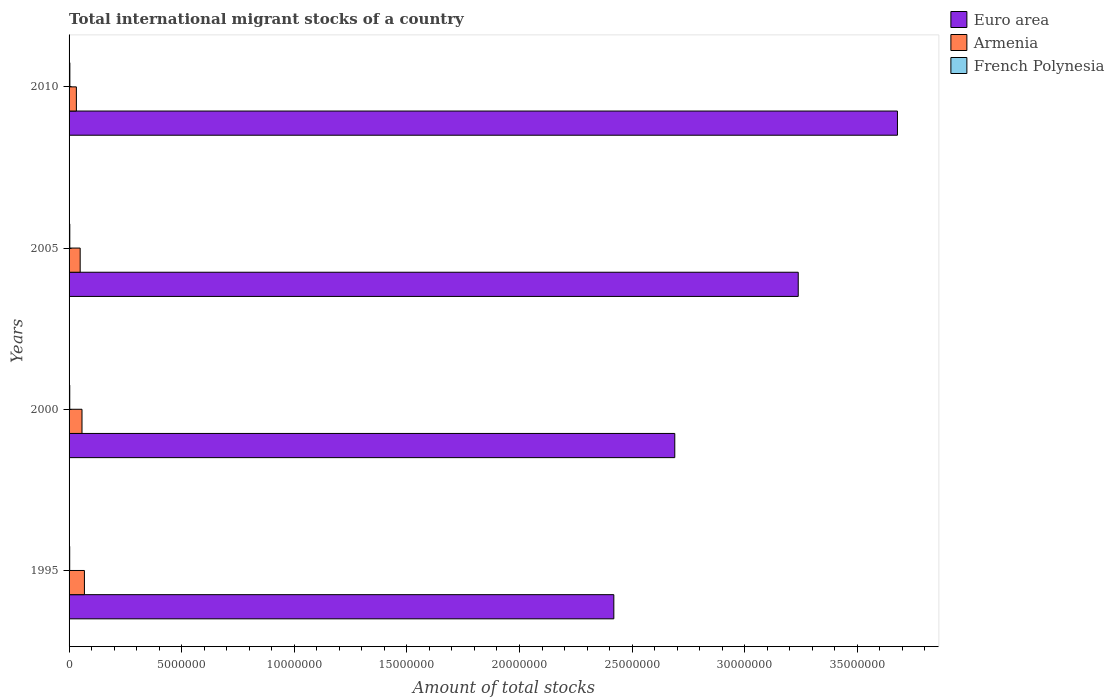Are the number of bars per tick equal to the number of legend labels?
Offer a terse response. Yes. Are the number of bars on each tick of the Y-axis equal?
Make the answer very short. Yes. What is the label of the 3rd group of bars from the top?
Offer a terse response. 2000. In how many cases, is the number of bars for a given year not equal to the number of legend labels?
Offer a very short reply. 0. What is the amount of total stocks in in Armenia in 2005?
Your answer should be very brief. 4.93e+05. Across all years, what is the maximum amount of total stocks in in Euro area?
Your answer should be very brief. 3.68e+07. Across all years, what is the minimum amount of total stocks in in Euro area?
Offer a very short reply. 2.42e+07. In which year was the amount of total stocks in in Euro area maximum?
Offer a very short reply. 2010. In which year was the amount of total stocks in in Euro area minimum?
Offer a very short reply. 1995. What is the total amount of total stocks in in Armenia in the graph?
Your answer should be compact. 2.07e+06. What is the difference between the amount of total stocks in in Euro area in 1995 and that in 2000?
Your answer should be compact. -2.71e+06. What is the difference between the amount of total stocks in in French Polynesia in 2010 and the amount of total stocks in in Euro area in 2005?
Ensure brevity in your answer.  -3.23e+07. What is the average amount of total stocks in in Armenia per year?
Provide a succinct answer. 5.18e+05. In the year 2000, what is the difference between the amount of total stocks in in French Polynesia and amount of total stocks in in Euro area?
Keep it short and to the point. -2.69e+07. What is the ratio of the amount of total stocks in in French Polynesia in 1995 to that in 2000?
Offer a terse response. 0.93. What is the difference between the highest and the second highest amount of total stocks in in French Polynesia?
Offer a terse response. 2314. What is the difference between the highest and the lowest amount of total stocks in in Euro area?
Keep it short and to the point. 1.26e+07. Is the sum of the amount of total stocks in in Armenia in 1995 and 2010 greater than the maximum amount of total stocks in in French Polynesia across all years?
Offer a terse response. Yes. What does the 1st bar from the top in 2005 represents?
Offer a very short reply. French Polynesia. What does the 3rd bar from the bottom in 1995 represents?
Keep it short and to the point. French Polynesia. How many years are there in the graph?
Ensure brevity in your answer.  4. What is the difference between two consecutive major ticks on the X-axis?
Your answer should be very brief. 5.00e+06. Are the values on the major ticks of X-axis written in scientific E-notation?
Give a very brief answer. No. How many legend labels are there?
Give a very brief answer. 3. How are the legend labels stacked?
Your answer should be very brief. Vertical. What is the title of the graph?
Offer a very short reply. Total international migrant stocks of a country. Does "Lesotho" appear as one of the legend labels in the graph?
Keep it short and to the point. No. What is the label or title of the X-axis?
Provide a short and direct response. Amount of total stocks. What is the label or title of the Y-axis?
Your answer should be very brief. Years. What is the Amount of total stocks in Euro area in 1995?
Keep it short and to the point. 2.42e+07. What is the Amount of total stocks of Armenia in 1995?
Make the answer very short. 6.82e+05. What is the Amount of total stocks of French Polynesia in 1995?
Offer a terse response. 2.82e+04. What is the Amount of total stocks of Euro area in 2000?
Your response must be concise. 2.69e+07. What is the Amount of total stocks of Armenia in 2000?
Offer a very short reply. 5.74e+05. What is the Amount of total stocks of French Polynesia in 2000?
Offer a terse response. 3.03e+04. What is the Amount of total stocks in Euro area in 2005?
Make the answer very short. 3.24e+07. What is the Amount of total stocks in Armenia in 2005?
Your answer should be very brief. 4.93e+05. What is the Amount of total stocks in French Polynesia in 2005?
Provide a short and direct response. 3.25e+04. What is the Amount of total stocks in Euro area in 2010?
Offer a very short reply. 3.68e+07. What is the Amount of total stocks of Armenia in 2010?
Provide a short and direct response. 3.24e+05. What is the Amount of total stocks of French Polynesia in 2010?
Provide a short and direct response. 3.48e+04. Across all years, what is the maximum Amount of total stocks in Euro area?
Give a very brief answer. 3.68e+07. Across all years, what is the maximum Amount of total stocks of Armenia?
Your response must be concise. 6.82e+05. Across all years, what is the maximum Amount of total stocks of French Polynesia?
Your response must be concise. 3.48e+04. Across all years, what is the minimum Amount of total stocks in Euro area?
Offer a terse response. 2.42e+07. Across all years, what is the minimum Amount of total stocks in Armenia?
Your response must be concise. 3.24e+05. Across all years, what is the minimum Amount of total stocks in French Polynesia?
Give a very brief answer. 2.82e+04. What is the total Amount of total stocks in Euro area in the graph?
Make the answer very short. 1.20e+08. What is the total Amount of total stocks in Armenia in the graph?
Offer a terse response. 2.07e+06. What is the total Amount of total stocks in French Polynesia in the graph?
Provide a succinct answer. 1.26e+05. What is the difference between the Amount of total stocks in Euro area in 1995 and that in 2000?
Your answer should be very brief. -2.71e+06. What is the difference between the Amount of total stocks in Armenia in 1995 and that in 2000?
Your answer should be compact. 1.07e+05. What is the difference between the Amount of total stocks of French Polynesia in 1995 and that in 2000?
Provide a succinct answer. -2140. What is the difference between the Amount of total stocks of Euro area in 1995 and that in 2005?
Your answer should be compact. -8.19e+06. What is the difference between the Amount of total stocks in Armenia in 1995 and that in 2005?
Offer a very short reply. 1.89e+05. What is the difference between the Amount of total stocks of French Polynesia in 1995 and that in 2005?
Keep it short and to the point. -4300. What is the difference between the Amount of total stocks in Euro area in 1995 and that in 2010?
Offer a terse response. -1.26e+07. What is the difference between the Amount of total stocks in Armenia in 1995 and that in 2010?
Your response must be concise. 3.57e+05. What is the difference between the Amount of total stocks in French Polynesia in 1995 and that in 2010?
Your answer should be very brief. -6614. What is the difference between the Amount of total stocks of Euro area in 2000 and that in 2005?
Give a very brief answer. -5.48e+06. What is the difference between the Amount of total stocks of Armenia in 2000 and that in 2005?
Your answer should be compact. 8.17e+04. What is the difference between the Amount of total stocks in French Polynesia in 2000 and that in 2005?
Make the answer very short. -2160. What is the difference between the Amount of total stocks of Euro area in 2000 and that in 2010?
Your answer should be very brief. -9.89e+06. What is the difference between the Amount of total stocks of Armenia in 2000 and that in 2010?
Keep it short and to the point. 2.50e+05. What is the difference between the Amount of total stocks of French Polynesia in 2000 and that in 2010?
Keep it short and to the point. -4474. What is the difference between the Amount of total stocks of Euro area in 2005 and that in 2010?
Your response must be concise. -4.41e+06. What is the difference between the Amount of total stocks in Armenia in 2005 and that in 2010?
Ensure brevity in your answer.  1.68e+05. What is the difference between the Amount of total stocks in French Polynesia in 2005 and that in 2010?
Your answer should be compact. -2314. What is the difference between the Amount of total stocks in Euro area in 1995 and the Amount of total stocks in Armenia in 2000?
Provide a short and direct response. 2.36e+07. What is the difference between the Amount of total stocks of Euro area in 1995 and the Amount of total stocks of French Polynesia in 2000?
Provide a succinct answer. 2.42e+07. What is the difference between the Amount of total stocks in Armenia in 1995 and the Amount of total stocks in French Polynesia in 2000?
Keep it short and to the point. 6.51e+05. What is the difference between the Amount of total stocks of Euro area in 1995 and the Amount of total stocks of Armenia in 2005?
Offer a very short reply. 2.37e+07. What is the difference between the Amount of total stocks of Euro area in 1995 and the Amount of total stocks of French Polynesia in 2005?
Give a very brief answer. 2.42e+07. What is the difference between the Amount of total stocks in Armenia in 1995 and the Amount of total stocks in French Polynesia in 2005?
Your answer should be compact. 6.49e+05. What is the difference between the Amount of total stocks of Euro area in 1995 and the Amount of total stocks of Armenia in 2010?
Provide a succinct answer. 2.39e+07. What is the difference between the Amount of total stocks of Euro area in 1995 and the Amount of total stocks of French Polynesia in 2010?
Your response must be concise. 2.42e+07. What is the difference between the Amount of total stocks of Armenia in 1995 and the Amount of total stocks of French Polynesia in 2010?
Make the answer very short. 6.47e+05. What is the difference between the Amount of total stocks in Euro area in 2000 and the Amount of total stocks in Armenia in 2005?
Give a very brief answer. 2.64e+07. What is the difference between the Amount of total stocks of Euro area in 2000 and the Amount of total stocks of French Polynesia in 2005?
Your answer should be compact. 2.69e+07. What is the difference between the Amount of total stocks of Armenia in 2000 and the Amount of total stocks of French Polynesia in 2005?
Provide a short and direct response. 5.42e+05. What is the difference between the Amount of total stocks of Euro area in 2000 and the Amount of total stocks of Armenia in 2010?
Your answer should be compact. 2.66e+07. What is the difference between the Amount of total stocks in Euro area in 2000 and the Amount of total stocks in French Polynesia in 2010?
Your answer should be very brief. 2.69e+07. What is the difference between the Amount of total stocks in Armenia in 2000 and the Amount of total stocks in French Polynesia in 2010?
Keep it short and to the point. 5.39e+05. What is the difference between the Amount of total stocks in Euro area in 2005 and the Amount of total stocks in Armenia in 2010?
Give a very brief answer. 3.21e+07. What is the difference between the Amount of total stocks of Euro area in 2005 and the Amount of total stocks of French Polynesia in 2010?
Offer a very short reply. 3.23e+07. What is the difference between the Amount of total stocks in Armenia in 2005 and the Amount of total stocks in French Polynesia in 2010?
Make the answer very short. 4.58e+05. What is the average Amount of total stocks of Euro area per year?
Keep it short and to the point. 3.01e+07. What is the average Amount of total stocks of Armenia per year?
Provide a short and direct response. 5.18e+05. What is the average Amount of total stocks in French Polynesia per year?
Make the answer very short. 3.15e+04. In the year 1995, what is the difference between the Amount of total stocks in Euro area and Amount of total stocks in Armenia?
Make the answer very short. 2.35e+07. In the year 1995, what is the difference between the Amount of total stocks in Euro area and Amount of total stocks in French Polynesia?
Ensure brevity in your answer.  2.42e+07. In the year 1995, what is the difference between the Amount of total stocks of Armenia and Amount of total stocks of French Polynesia?
Provide a short and direct response. 6.53e+05. In the year 2000, what is the difference between the Amount of total stocks in Euro area and Amount of total stocks in Armenia?
Your response must be concise. 2.63e+07. In the year 2000, what is the difference between the Amount of total stocks in Euro area and Amount of total stocks in French Polynesia?
Your answer should be very brief. 2.69e+07. In the year 2000, what is the difference between the Amount of total stocks of Armenia and Amount of total stocks of French Polynesia?
Ensure brevity in your answer.  5.44e+05. In the year 2005, what is the difference between the Amount of total stocks of Euro area and Amount of total stocks of Armenia?
Your answer should be compact. 3.19e+07. In the year 2005, what is the difference between the Amount of total stocks of Euro area and Amount of total stocks of French Polynesia?
Offer a very short reply. 3.23e+07. In the year 2005, what is the difference between the Amount of total stocks of Armenia and Amount of total stocks of French Polynesia?
Keep it short and to the point. 4.60e+05. In the year 2010, what is the difference between the Amount of total stocks in Euro area and Amount of total stocks in Armenia?
Offer a terse response. 3.65e+07. In the year 2010, what is the difference between the Amount of total stocks of Euro area and Amount of total stocks of French Polynesia?
Ensure brevity in your answer.  3.67e+07. In the year 2010, what is the difference between the Amount of total stocks in Armenia and Amount of total stocks in French Polynesia?
Your answer should be compact. 2.89e+05. What is the ratio of the Amount of total stocks of Euro area in 1995 to that in 2000?
Your answer should be very brief. 0.9. What is the ratio of the Amount of total stocks in Armenia in 1995 to that in 2000?
Your response must be concise. 1.19. What is the ratio of the Amount of total stocks in French Polynesia in 1995 to that in 2000?
Your answer should be very brief. 0.93. What is the ratio of the Amount of total stocks in Euro area in 1995 to that in 2005?
Ensure brevity in your answer.  0.75. What is the ratio of the Amount of total stocks of Armenia in 1995 to that in 2005?
Make the answer very short. 1.38. What is the ratio of the Amount of total stocks in French Polynesia in 1995 to that in 2005?
Make the answer very short. 0.87. What is the ratio of the Amount of total stocks in Euro area in 1995 to that in 2010?
Your response must be concise. 0.66. What is the ratio of the Amount of total stocks in Armenia in 1995 to that in 2010?
Offer a terse response. 2.1. What is the ratio of the Amount of total stocks of French Polynesia in 1995 to that in 2010?
Your answer should be compact. 0.81. What is the ratio of the Amount of total stocks of Euro area in 2000 to that in 2005?
Provide a succinct answer. 0.83. What is the ratio of the Amount of total stocks in Armenia in 2000 to that in 2005?
Offer a terse response. 1.17. What is the ratio of the Amount of total stocks of French Polynesia in 2000 to that in 2005?
Provide a succinct answer. 0.93. What is the ratio of the Amount of total stocks of Euro area in 2000 to that in 2010?
Provide a succinct answer. 0.73. What is the ratio of the Amount of total stocks of Armenia in 2000 to that in 2010?
Ensure brevity in your answer.  1.77. What is the ratio of the Amount of total stocks in French Polynesia in 2000 to that in 2010?
Your answer should be compact. 0.87. What is the ratio of the Amount of total stocks in Euro area in 2005 to that in 2010?
Offer a terse response. 0.88. What is the ratio of the Amount of total stocks in Armenia in 2005 to that in 2010?
Give a very brief answer. 1.52. What is the ratio of the Amount of total stocks in French Polynesia in 2005 to that in 2010?
Keep it short and to the point. 0.93. What is the difference between the highest and the second highest Amount of total stocks of Euro area?
Provide a succinct answer. 4.41e+06. What is the difference between the highest and the second highest Amount of total stocks of Armenia?
Provide a short and direct response. 1.07e+05. What is the difference between the highest and the second highest Amount of total stocks in French Polynesia?
Offer a very short reply. 2314. What is the difference between the highest and the lowest Amount of total stocks in Euro area?
Your answer should be compact. 1.26e+07. What is the difference between the highest and the lowest Amount of total stocks of Armenia?
Keep it short and to the point. 3.57e+05. What is the difference between the highest and the lowest Amount of total stocks of French Polynesia?
Keep it short and to the point. 6614. 